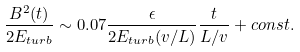Convert formula to latex. <formula><loc_0><loc_0><loc_500><loc_500>\frac { B ^ { 2 } ( t ) } { 2 E _ { t u r b } } \sim 0 . 0 7 \frac { \epsilon } { 2 E _ { t u r b } ( v / L ) } \frac { t } { L / v } + c o n s t .</formula> 